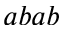Convert formula to latex. <formula><loc_0><loc_0><loc_500><loc_500>a b a b</formula> 